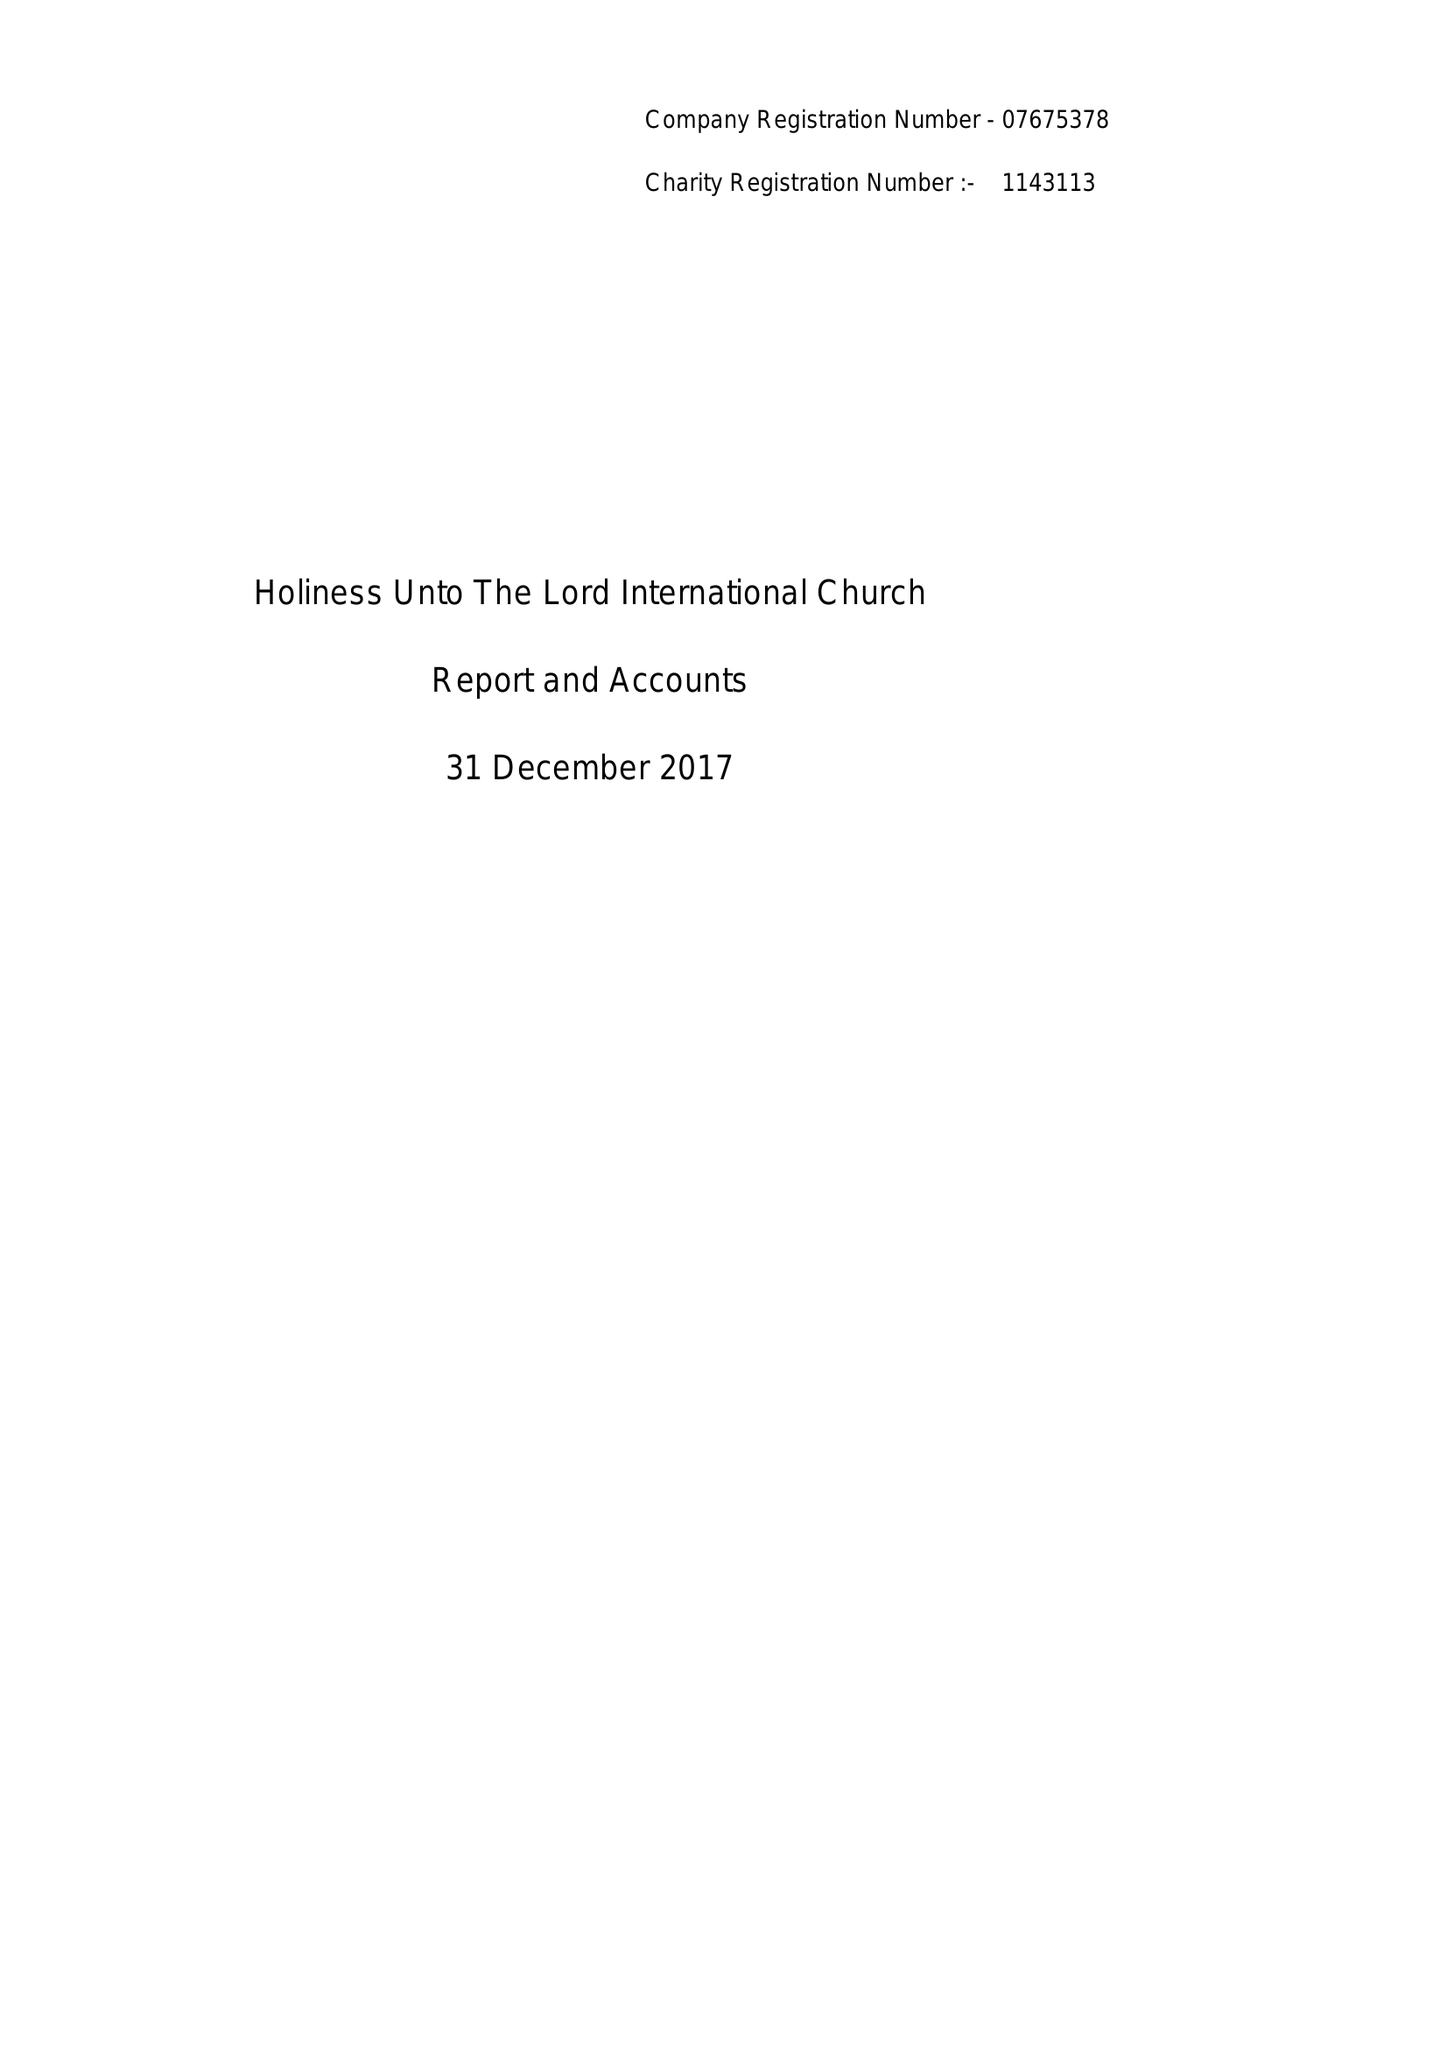What is the value for the address__post_town?
Answer the question using a single word or phrase. LONDON 